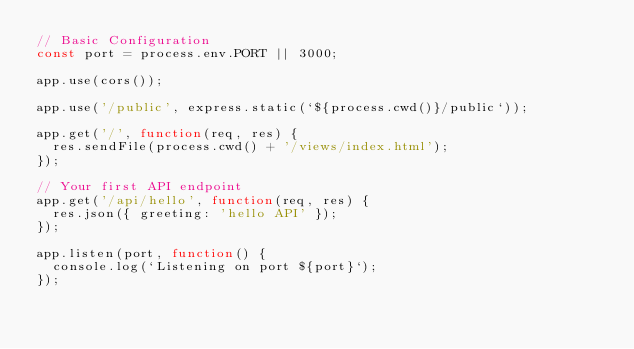Convert code to text. <code><loc_0><loc_0><loc_500><loc_500><_JavaScript_>// Basic Configuration
const port = process.env.PORT || 3000;

app.use(cors());

app.use('/public', express.static(`${process.cwd()}/public`));

app.get('/', function(req, res) {
  res.sendFile(process.cwd() + '/views/index.html');
});

// Your first API endpoint
app.get('/api/hello', function(req, res) {
  res.json({ greeting: 'hello API' });
});

app.listen(port, function() {
  console.log(`Listening on port ${port}`);
});
</code> 